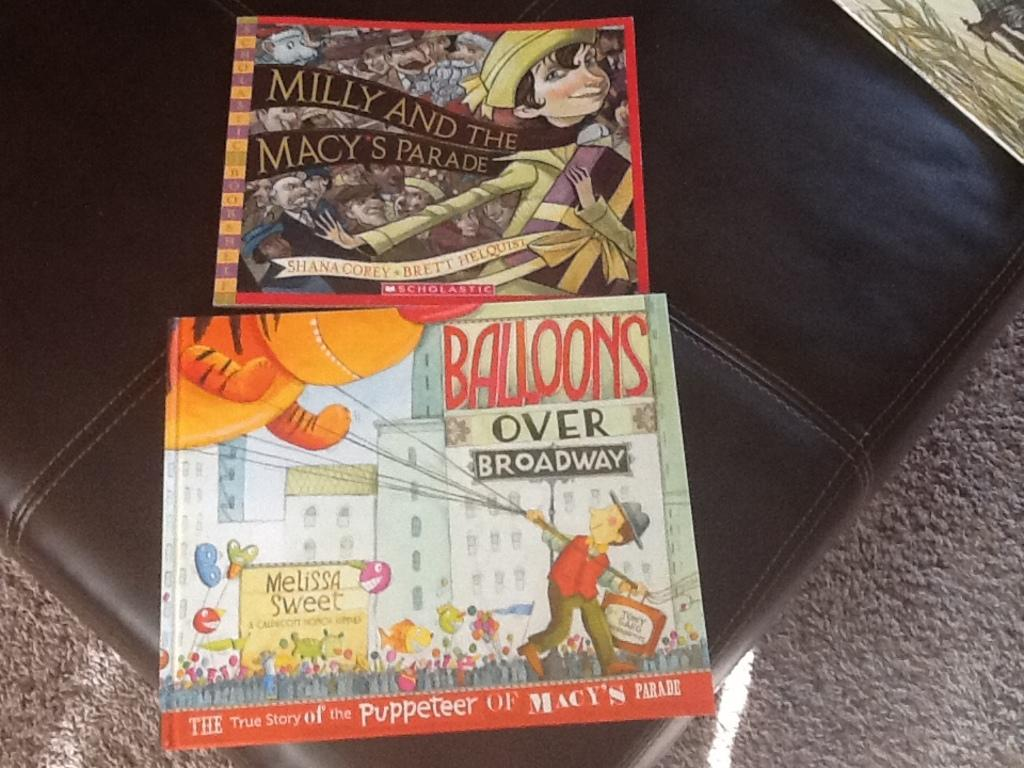<image>
Provide a brief description of the given image. Milly and the Macy's Parade" was above "Balllons over Broadway 